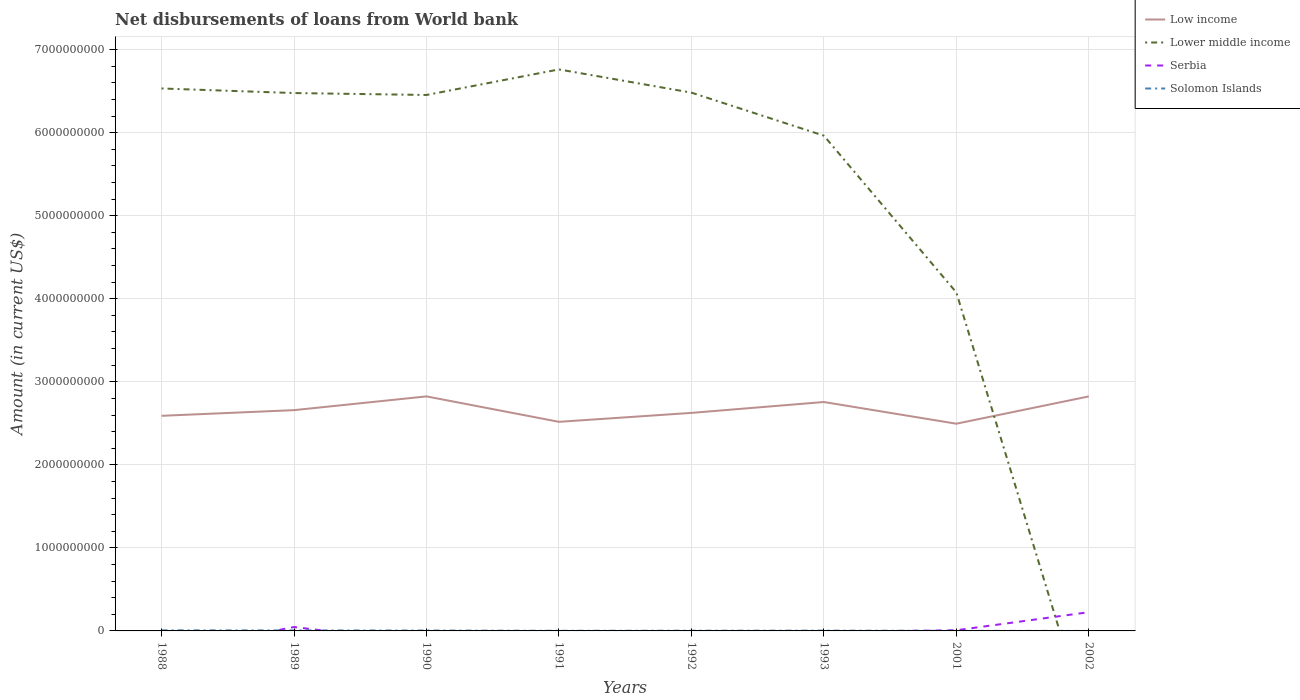Does the line corresponding to Solomon Islands intersect with the line corresponding to Low income?
Your answer should be very brief. No. What is the total amount of loan disbursed from World Bank in Low income in the graph?
Your answer should be very brief. -2.34e+08. What is the difference between the highest and the second highest amount of loan disbursed from World Bank in Lower middle income?
Your answer should be very brief. 6.76e+09. Is the amount of loan disbursed from World Bank in Solomon Islands strictly greater than the amount of loan disbursed from World Bank in Low income over the years?
Ensure brevity in your answer.  Yes. Are the values on the major ticks of Y-axis written in scientific E-notation?
Your response must be concise. No. Does the graph contain grids?
Keep it short and to the point. Yes. How are the legend labels stacked?
Offer a terse response. Vertical. What is the title of the graph?
Offer a very short reply. Net disbursements of loans from World bank. Does "Maldives" appear as one of the legend labels in the graph?
Keep it short and to the point. No. What is the label or title of the X-axis?
Make the answer very short. Years. What is the Amount (in current US$) in Low income in 1988?
Ensure brevity in your answer.  2.59e+09. What is the Amount (in current US$) of Lower middle income in 1988?
Your answer should be compact. 6.53e+09. What is the Amount (in current US$) in Solomon Islands in 1988?
Ensure brevity in your answer.  7.18e+06. What is the Amount (in current US$) in Low income in 1989?
Your response must be concise. 2.66e+09. What is the Amount (in current US$) in Lower middle income in 1989?
Your answer should be very brief. 6.48e+09. What is the Amount (in current US$) in Serbia in 1989?
Offer a very short reply. 4.69e+07. What is the Amount (in current US$) of Solomon Islands in 1989?
Provide a short and direct response. 6.07e+06. What is the Amount (in current US$) of Low income in 1990?
Your answer should be very brief. 2.82e+09. What is the Amount (in current US$) in Lower middle income in 1990?
Keep it short and to the point. 6.45e+09. What is the Amount (in current US$) in Serbia in 1990?
Give a very brief answer. 0. What is the Amount (in current US$) of Solomon Islands in 1990?
Ensure brevity in your answer.  4.68e+06. What is the Amount (in current US$) in Low income in 1991?
Offer a very short reply. 2.52e+09. What is the Amount (in current US$) in Lower middle income in 1991?
Your answer should be very brief. 6.76e+09. What is the Amount (in current US$) of Solomon Islands in 1991?
Keep it short and to the point. 1.68e+06. What is the Amount (in current US$) of Low income in 1992?
Offer a terse response. 2.63e+09. What is the Amount (in current US$) in Lower middle income in 1992?
Ensure brevity in your answer.  6.48e+09. What is the Amount (in current US$) in Solomon Islands in 1992?
Your answer should be compact. 2.63e+06. What is the Amount (in current US$) in Low income in 1993?
Give a very brief answer. 2.76e+09. What is the Amount (in current US$) in Lower middle income in 1993?
Offer a terse response. 5.96e+09. What is the Amount (in current US$) of Solomon Islands in 1993?
Provide a short and direct response. 3.58e+06. What is the Amount (in current US$) in Low income in 2001?
Provide a succinct answer. 2.50e+09. What is the Amount (in current US$) of Lower middle income in 2001?
Give a very brief answer. 4.08e+09. What is the Amount (in current US$) of Serbia in 2001?
Your answer should be compact. 7.92e+06. What is the Amount (in current US$) of Solomon Islands in 2001?
Provide a short and direct response. 9.77e+05. What is the Amount (in current US$) in Low income in 2002?
Offer a very short reply. 2.82e+09. What is the Amount (in current US$) in Lower middle income in 2002?
Your answer should be very brief. 0. What is the Amount (in current US$) in Serbia in 2002?
Provide a short and direct response. 2.26e+08. What is the Amount (in current US$) in Solomon Islands in 2002?
Your response must be concise. 0. Across all years, what is the maximum Amount (in current US$) in Low income?
Your response must be concise. 2.82e+09. Across all years, what is the maximum Amount (in current US$) of Lower middle income?
Offer a terse response. 6.76e+09. Across all years, what is the maximum Amount (in current US$) in Serbia?
Offer a very short reply. 2.26e+08. Across all years, what is the maximum Amount (in current US$) of Solomon Islands?
Your answer should be very brief. 7.18e+06. Across all years, what is the minimum Amount (in current US$) of Low income?
Provide a short and direct response. 2.50e+09. Across all years, what is the minimum Amount (in current US$) in Serbia?
Offer a terse response. 0. Across all years, what is the minimum Amount (in current US$) of Solomon Islands?
Make the answer very short. 0. What is the total Amount (in current US$) of Low income in the graph?
Your answer should be compact. 2.13e+1. What is the total Amount (in current US$) of Lower middle income in the graph?
Offer a very short reply. 4.27e+1. What is the total Amount (in current US$) of Serbia in the graph?
Provide a succinct answer. 2.81e+08. What is the total Amount (in current US$) of Solomon Islands in the graph?
Give a very brief answer. 2.68e+07. What is the difference between the Amount (in current US$) in Low income in 1988 and that in 1989?
Provide a succinct answer. -6.82e+07. What is the difference between the Amount (in current US$) of Lower middle income in 1988 and that in 1989?
Your response must be concise. 5.51e+07. What is the difference between the Amount (in current US$) of Solomon Islands in 1988 and that in 1989?
Your answer should be very brief. 1.12e+06. What is the difference between the Amount (in current US$) in Low income in 1988 and that in 1990?
Your answer should be very brief. -2.34e+08. What is the difference between the Amount (in current US$) of Lower middle income in 1988 and that in 1990?
Offer a very short reply. 7.83e+07. What is the difference between the Amount (in current US$) of Solomon Islands in 1988 and that in 1990?
Give a very brief answer. 2.51e+06. What is the difference between the Amount (in current US$) of Low income in 1988 and that in 1991?
Offer a terse response. 7.25e+07. What is the difference between the Amount (in current US$) in Lower middle income in 1988 and that in 1991?
Provide a short and direct response. -2.29e+08. What is the difference between the Amount (in current US$) of Solomon Islands in 1988 and that in 1991?
Provide a succinct answer. 5.50e+06. What is the difference between the Amount (in current US$) of Low income in 1988 and that in 1992?
Keep it short and to the point. -3.51e+07. What is the difference between the Amount (in current US$) in Lower middle income in 1988 and that in 1992?
Your answer should be compact. 5.02e+07. What is the difference between the Amount (in current US$) of Solomon Islands in 1988 and that in 1992?
Offer a very short reply. 4.55e+06. What is the difference between the Amount (in current US$) of Low income in 1988 and that in 1993?
Offer a very short reply. -1.66e+08. What is the difference between the Amount (in current US$) in Lower middle income in 1988 and that in 1993?
Your response must be concise. 5.68e+08. What is the difference between the Amount (in current US$) in Solomon Islands in 1988 and that in 1993?
Provide a short and direct response. 3.60e+06. What is the difference between the Amount (in current US$) in Low income in 1988 and that in 2001?
Your response must be concise. 9.52e+07. What is the difference between the Amount (in current US$) of Lower middle income in 1988 and that in 2001?
Offer a very short reply. 2.46e+09. What is the difference between the Amount (in current US$) in Solomon Islands in 1988 and that in 2001?
Provide a short and direct response. 6.21e+06. What is the difference between the Amount (in current US$) in Low income in 1988 and that in 2002?
Your response must be concise. -2.34e+08. What is the difference between the Amount (in current US$) of Low income in 1989 and that in 1990?
Make the answer very short. -1.66e+08. What is the difference between the Amount (in current US$) of Lower middle income in 1989 and that in 1990?
Offer a very short reply. 2.32e+07. What is the difference between the Amount (in current US$) of Solomon Islands in 1989 and that in 1990?
Provide a succinct answer. 1.39e+06. What is the difference between the Amount (in current US$) in Low income in 1989 and that in 1991?
Offer a terse response. 1.41e+08. What is the difference between the Amount (in current US$) of Lower middle income in 1989 and that in 1991?
Keep it short and to the point. -2.84e+08. What is the difference between the Amount (in current US$) in Solomon Islands in 1989 and that in 1991?
Your response must be concise. 4.39e+06. What is the difference between the Amount (in current US$) in Low income in 1989 and that in 1992?
Your answer should be very brief. 3.31e+07. What is the difference between the Amount (in current US$) in Lower middle income in 1989 and that in 1992?
Offer a very short reply. -4.91e+06. What is the difference between the Amount (in current US$) of Solomon Islands in 1989 and that in 1992?
Your answer should be very brief. 3.43e+06. What is the difference between the Amount (in current US$) of Low income in 1989 and that in 1993?
Ensure brevity in your answer.  -9.79e+07. What is the difference between the Amount (in current US$) of Lower middle income in 1989 and that in 1993?
Ensure brevity in your answer.  5.13e+08. What is the difference between the Amount (in current US$) of Solomon Islands in 1989 and that in 1993?
Provide a short and direct response. 2.49e+06. What is the difference between the Amount (in current US$) in Low income in 1989 and that in 2001?
Keep it short and to the point. 1.63e+08. What is the difference between the Amount (in current US$) of Lower middle income in 1989 and that in 2001?
Provide a short and direct response. 2.40e+09. What is the difference between the Amount (in current US$) of Serbia in 1989 and that in 2001?
Keep it short and to the point. 3.90e+07. What is the difference between the Amount (in current US$) in Solomon Islands in 1989 and that in 2001?
Offer a terse response. 5.09e+06. What is the difference between the Amount (in current US$) of Low income in 1989 and that in 2002?
Give a very brief answer. -1.65e+08. What is the difference between the Amount (in current US$) of Serbia in 1989 and that in 2002?
Keep it short and to the point. -1.79e+08. What is the difference between the Amount (in current US$) of Low income in 1990 and that in 1991?
Offer a terse response. 3.06e+08. What is the difference between the Amount (in current US$) of Lower middle income in 1990 and that in 1991?
Keep it short and to the point. -3.08e+08. What is the difference between the Amount (in current US$) of Solomon Islands in 1990 and that in 1991?
Ensure brevity in your answer.  3.00e+06. What is the difference between the Amount (in current US$) in Low income in 1990 and that in 1992?
Your response must be concise. 1.99e+08. What is the difference between the Amount (in current US$) of Lower middle income in 1990 and that in 1992?
Your answer should be compact. -2.81e+07. What is the difference between the Amount (in current US$) in Solomon Islands in 1990 and that in 1992?
Your response must be concise. 2.04e+06. What is the difference between the Amount (in current US$) of Low income in 1990 and that in 1993?
Keep it short and to the point. 6.77e+07. What is the difference between the Amount (in current US$) in Lower middle income in 1990 and that in 1993?
Provide a short and direct response. 4.90e+08. What is the difference between the Amount (in current US$) of Solomon Islands in 1990 and that in 1993?
Your answer should be compact. 1.10e+06. What is the difference between the Amount (in current US$) of Low income in 1990 and that in 2001?
Give a very brief answer. 3.29e+08. What is the difference between the Amount (in current US$) in Lower middle income in 1990 and that in 2001?
Ensure brevity in your answer.  2.38e+09. What is the difference between the Amount (in current US$) in Solomon Islands in 1990 and that in 2001?
Provide a short and direct response. 3.70e+06. What is the difference between the Amount (in current US$) of Low income in 1990 and that in 2002?
Give a very brief answer. 9.60e+04. What is the difference between the Amount (in current US$) of Low income in 1991 and that in 1992?
Your answer should be compact. -1.08e+08. What is the difference between the Amount (in current US$) in Lower middle income in 1991 and that in 1992?
Keep it short and to the point. 2.80e+08. What is the difference between the Amount (in current US$) in Solomon Islands in 1991 and that in 1992?
Your response must be concise. -9.54e+05. What is the difference between the Amount (in current US$) of Low income in 1991 and that in 1993?
Your response must be concise. -2.39e+08. What is the difference between the Amount (in current US$) in Lower middle income in 1991 and that in 1993?
Ensure brevity in your answer.  7.98e+08. What is the difference between the Amount (in current US$) in Solomon Islands in 1991 and that in 1993?
Keep it short and to the point. -1.90e+06. What is the difference between the Amount (in current US$) in Low income in 1991 and that in 2001?
Offer a terse response. 2.27e+07. What is the difference between the Amount (in current US$) of Lower middle income in 1991 and that in 2001?
Offer a terse response. 2.69e+09. What is the difference between the Amount (in current US$) of Solomon Islands in 1991 and that in 2001?
Offer a very short reply. 7.02e+05. What is the difference between the Amount (in current US$) in Low income in 1991 and that in 2002?
Keep it short and to the point. -3.06e+08. What is the difference between the Amount (in current US$) of Low income in 1992 and that in 1993?
Give a very brief answer. -1.31e+08. What is the difference between the Amount (in current US$) of Lower middle income in 1992 and that in 1993?
Your answer should be compact. 5.18e+08. What is the difference between the Amount (in current US$) of Solomon Islands in 1992 and that in 1993?
Keep it short and to the point. -9.46e+05. What is the difference between the Amount (in current US$) of Low income in 1992 and that in 2001?
Offer a very short reply. 1.30e+08. What is the difference between the Amount (in current US$) in Lower middle income in 1992 and that in 2001?
Your response must be concise. 2.41e+09. What is the difference between the Amount (in current US$) of Solomon Islands in 1992 and that in 2001?
Your answer should be very brief. 1.66e+06. What is the difference between the Amount (in current US$) of Low income in 1992 and that in 2002?
Your answer should be compact. -1.99e+08. What is the difference between the Amount (in current US$) of Low income in 1993 and that in 2001?
Offer a terse response. 2.61e+08. What is the difference between the Amount (in current US$) in Lower middle income in 1993 and that in 2001?
Your answer should be compact. 1.89e+09. What is the difference between the Amount (in current US$) in Solomon Islands in 1993 and that in 2001?
Your response must be concise. 2.60e+06. What is the difference between the Amount (in current US$) of Low income in 1993 and that in 2002?
Give a very brief answer. -6.76e+07. What is the difference between the Amount (in current US$) of Low income in 2001 and that in 2002?
Keep it short and to the point. -3.29e+08. What is the difference between the Amount (in current US$) in Serbia in 2001 and that in 2002?
Your response must be concise. -2.18e+08. What is the difference between the Amount (in current US$) of Low income in 1988 and the Amount (in current US$) of Lower middle income in 1989?
Make the answer very short. -3.89e+09. What is the difference between the Amount (in current US$) of Low income in 1988 and the Amount (in current US$) of Serbia in 1989?
Provide a short and direct response. 2.54e+09. What is the difference between the Amount (in current US$) in Low income in 1988 and the Amount (in current US$) in Solomon Islands in 1989?
Offer a terse response. 2.58e+09. What is the difference between the Amount (in current US$) of Lower middle income in 1988 and the Amount (in current US$) of Serbia in 1989?
Your answer should be very brief. 6.49e+09. What is the difference between the Amount (in current US$) of Lower middle income in 1988 and the Amount (in current US$) of Solomon Islands in 1989?
Your answer should be very brief. 6.53e+09. What is the difference between the Amount (in current US$) in Low income in 1988 and the Amount (in current US$) in Lower middle income in 1990?
Your answer should be compact. -3.86e+09. What is the difference between the Amount (in current US$) of Low income in 1988 and the Amount (in current US$) of Solomon Islands in 1990?
Your response must be concise. 2.59e+09. What is the difference between the Amount (in current US$) in Lower middle income in 1988 and the Amount (in current US$) in Solomon Islands in 1990?
Offer a terse response. 6.53e+09. What is the difference between the Amount (in current US$) of Low income in 1988 and the Amount (in current US$) of Lower middle income in 1991?
Your answer should be very brief. -4.17e+09. What is the difference between the Amount (in current US$) in Low income in 1988 and the Amount (in current US$) in Solomon Islands in 1991?
Your answer should be compact. 2.59e+09. What is the difference between the Amount (in current US$) of Lower middle income in 1988 and the Amount (in current US$) of Solomon Islands in 1991?
Make the answer very short. 6.53e+09. What is the difference between the Amount (in current US$) in Low income in 1988 and the Amount (in current US$) in Lower middle income in 1992?
Ensure brevity in your answer.  -3.89e+09. What is the difference between the Amount (in current US$) of Low income in 1988 and the Amount (in current US$) of Solomon Islands in 1992?
Provide a succinct answer. 2.59e+09. What is the difference between the Amount (in current US$) of Lower middle income in 1988 and the Amount (in current US$) of Solomon Islands in 1992?
Make the answer very short. 6.53e+09. What is the difference between the Amount (in current US$) of Low income in 1988 and the Amount (in current US$) of Lower middle income in 1993?
Keep it short and to the point. -3.37e+09. What is the difference between the Amount (in current US$) in Low income in 1988 and the Amount (in current US$) in Solomon Islands in 1993?
Your answer should be very brief. 2.59e+09. What is the difference between the Amount (in current US$) in Lower middle income in 1988 and the Amount (in current US$) in Solomon Islands in 1993?
Provide a short and direct response. 6.53e+09. What is the difference between the Amount (in current US$) in Low income in 1988 and the Amount (in current US$) in Lower middle income in 2001?
Provide a succinct answer. -1.49e+09. What is the difference between the Amount (in current US$) in Low income in 1988 and the Amount (in current US$) in Serbia in 2001?
Your response must be concise. 2.58e+09. What is the difference between the Amount (in current US$) in Low income in 1988 and the Amount (in current US$) in Solomon Islands in 2001?
Keep it short and to the point. 2.59e+09. What is the difference between the Amount (in current US$) in Lower middle income in 1988 and the Amount (in current US$) in Serbia in 2001?
Offer a terse response. 6.52e+09. What is the difference between the Amount (in current US$) in Lower middle income in 1988 and the Amount (in current US$) in Solomon Islands in 2001?
Your answer should be very brief. 6.53e+09. What is the difference between the Amount (in current US$) of Low income in 1988 and the Amount (in current US$) of Serbia in 2002?
Keep it short and to the point. 2.36e+09. What is the difference between the Amount (in current US$) of Lower middle income in 1988 and the Amount (in current US$) of Serbia in 2002?
Provide a succinct answer. 6.31e+09. What is the difference between the Amount (in current US$) of Low income in 1989 and the Amount (in current US$) of Lower middle income in 1990?
Offer a terse response. -3.80e+09. What is the difference between the Amount (in current US$) in Low income in 1989 and the Amount (in current US$) in Solomon Islands in 1990?
Your response must be concise. 2.65e+09. What is the difference between the Amount (in current US$) of Lower middle income in 1989 and the Amount (in current US$) of Solomon Islands in 1990?
Offer a terse response. 6.47e+09. What is the difference between the Amount (in current US$) in Serbia in 1989 and the Amount (in current US$) in Solomon Islands in 1990?
Provide a short and direct response. 4.22e+07. What is the difference between the Amount (in current US$) in Low income in 1989 and the Amount (in current US$) in Lower middle income in 1991?
Your answer should be very brief. -4.10e+09. What is the difference between the Amount (in current US$) of Low income in 1989 and the Amount (in current US$) of Solomon Islands in 1991?
Make the answer very short. 2.66e+09. What is the difference between the Amount (in current US$) of Lower middle income in 1989 and the Amount (in current US$) of Solomon Islands in 1991?
Provide a succinct answer. 6.48e+09. What is the difference between the Amount (in current US$) in Serbia in 1989 and the Amount (in current US$) in Solomon Islands in 1991?
Ensure brevity in your answer.  4.52e+07. What is the difference between the Amount (in current US$) of Low income in 1989 and the Amount (in current US$) of Lower middle income in 1992?
Your answer should be very brief. -3.82e+09. What is the difference between the Amount (in current US$) in Low income in 1989 and the Amount (in current US$) in Solomon Islands in 1992?
Your response must be concise. 2.66e+09. What is the difference between the Amount (in current US$) of Lower middle income in 1989 and the Amount (in current US$) of Solomon Islands in 1992?
Your answer should be very brief. 6.47e+09. What is the difference between the Amount (in current US$) of Serbia in 1989 and the Amount (in current US$) of Solomon Islands in 1992?
Make the answer very short. 4.43e+07. What is the difference between the Amount (in current US$) of Low income in 1989 and the Amount (in current US$) of Lower middle income in 1993?
Provide a succinct answer. -3.31e+09. What is the difference between the Amount (in current US$) in Low income in 1989 and the Amount (in current US$) in Solomon Islands in 1993?
Give a very brief answer. 2.66e+09. What is the difference between the Amount (in current US$) in Lower middle income in 1989 and the Amount (in current US$) in Solomon Islands in 1993?
Provide a short and direct response. 6.47e+09. What is the difference between the Amount (in current US$) in Serbia in 1989 and the Amount (in current US$) in Solomon Islands in 1993?
Ensure brevity in your answer.  4.33e+07. What is the difference between the Amount (in current US$) in Low income in 1989 and the Amount (in current US$) in Lower middle income in 2001?
Your response must be concise. -1.42e+09. What is the difference between the Amount (in current US$) of Low income in 1989 and the Amount (in current US$) of Serbia in 2001?
Your answer should be very brief. 2.65e+09. What is the difference between the Amount (in current US$) of Low income in 1989 and the Amount (in current US$) of Solomon Islands in 2001?
Your answer should be compact. 2.66e+09. What is the difference between the Amount (in current US$) in Lower middle income in 1989 and the Amount (in current US$) in Serbia in 2001?
Give a very brief answer. 6.47e+09. What is the difference between the Amount (in current US$) of Lower middle income in 1989 and the Amount (in current US$) of Solomon Islands in 2001?
Offer a very short reply. 6.48e+09. What is the difference between the Amount (in current US$) in Serbia in 1989 and the Amount (in current US$) in Solomon Islands in 2001?
Offer a very short reply. 4.59e+07. What is the difference between the Amount (in current US$) in Low income in 1989 and the Amount (in current US$) in Serbia in 2002?
Your answer should be very brief. 2.43e+09. What is the difference between the Amount (in current US$) in Lower middle income in 1989 and the Amount (in current US$) in Serbia in 2002?
Make the answer very short. 6.25e+09. What is the difference between the Amount (in current US$) in Low income in 1990 and the Amount (in current US$) in Lower middle income in 1991?
Provide a short and direct response. -3.94e+09. What is the difference between the Amount (in current US$) of Low income in 1990 and the Amount (in current US$) of Solomon Islands in 1991?
Offer a very short reply. 2.82e+09. What is the difference between the Amount (in current US$) of Lower middle income in 1990 and the Amount (in current US$) of Solomon Islands in 1991?
Ensure brevity in your answer.  6.45e+09. What is the difference between the Amount (in current US$) of Low income in 1990 and the Amount (in current US$) of Lower middle income in 1992?
Keep it short and to the point. -3.66e+09. What is the difference between the Amount (in current US$) of Low income in 1990 and the Amount (in current US$) of Solomon Islands in 1992?
Provide a succinct answer. 2.82e+09. What is the difference between the Amount (in current US$) in Lower middle income in 1990 and the Amount (in current US$) in Solomon Islands in 1992?
Make the answer very short. 6.45e+09. What is the difference between the Amount (in current US$) in Low income in 1990 and the Amount (in current US$) in Lower middle income in 1993?
Offer a very short reply. -3.14e+09. What is the difference between the Amount (in current US$) of Low income in 1990 and the Amount (in current US$) of Solomon Islands in 1993?
Ensure brevity in your answer.  2.82e+09. What is the difference between the Amount (in current US$) of Lower middle income in 1990 and the Amount (in current US$) of Solomon Islands in 1993?
Provide a succinct answer. 6.45e+09. What is the difference between the Amount (in current US$) in Low income in 1990 and the Amount (in current US$) in Lower middle income in 2001?
Your answer should be compact. -1.25e+09. What is the difference between the Amount (in current US$) in Low income in 1990 and the Amount (in current US$) in Serbia in 2001?
Your answer should be compact. 2.82e+09. What is the difference between the Amount (in current US$) in Low income in 1990 and the Amount (in current US$) in Solomon Islands in 2001?
Provide a short and direct response. 2.82e+09. What is the difference between the Amount (in current US$) of Lower middle income in 1990 and the Amount (in current US$) of Serbia in 2001?
Your answer should be very brief. 6.45e+09. What is the difference between the Amount (in current US$) of Lower middle income in 1990 and the Amount (in current US$) of Solomon Islands in 2001?
Your answer should be compact. 6.45e+09. What is the difference between the Amount (in current US$) in Low income in 1990 and the Amount (in current US$) in Serbia in 2002?
Make the answer very short. 2.60e+09. What is the difference between the Amount (in current US$) in Lower middle income in 1990 and the Amount (in current US$) in Serbia in 2002?
Ensure brevity in your answer.  6.23e+09. What is the difference between the Amount (in current US$) of Low income in 1991 and the Amount (in current US$) of Lower middle income in 1992?
Keep it short and to the point. -3.96e+09. What is the difference between the Amount (in current US$) in Low income in 1991 and the Amount (in current US$) in Solomon Islands in 1992?
Ensure brevity in your answer.  2.52e+09. What is the difference between the Amount (in current US$) in Lower middle income in 1991 and the Amount (in current US$) in Solomon Islands in 1992?
Offer a terse response. 6.76e+09. What is the difference between the Amount (in current US$) in Low income in 1991 and the Amount (in current US$) in Lower middle income in 1993?
Offer a terse response. -3.45e+09. What is the difference between the Amount (in current US$) of Low income in 1991 and the Amount (in current US$) of Solomon Islands in 1993?
Make the answer very short. 2.51e+09. What is the difference between the Amount (in current US$) in Lower middle income in 1991 and the Amount (in current US$) in Solomon Islands in 1993?
Your answer should be very brief. 6.76e+09. What is the difference between the Amount (in current US$) in Low income in 1991 and the Amount (in current US$) in Lower middle income in 2001?
Your response must be concise. -1.56e+09. What is the difference between the Amount (in current US$) of Low income in 1991 and the Amount (in current US$) of Serbia in 2001?
Your answer should be compact. 2.51e+09. What is the difference between the Amount (in current US$) in Low income in 1991 and the Amount (in current US$) in Solomon Islands in 2001?
Provide a succinct answer. 2.52e+09. What is the difference between the Amount (in current US$) in Lower middle income in 1991 and the Amount (in current US$) in Serbia in 2001?
Give a very brief answer. 6.75e+09. What is the difference between the Amount (in current US$) in Lower middle income in 1991 and the Amount (in current US$) in Solomon Islands in 2001?
Provide a short and direct response. 6.76e+09. What is the difference between the Amount (in current US$) of Low income in 1991 and the Amount (in current US$) of Serbia in 2002?
Keep it short and to the point. 2.29e+09. What is the difference between the Amount (in current US$) of Lower middle income in 1991 and the Amount (in current US$) of Serbia in 2002?
Your answer should be very brief. 6.54e+09. What is the difference between the Amount (in current US$) of Low income in 1992 and the Amount (in current US$) of Lower middle income in 1993?
Provide a succinct answer. -3.34e+09. What is the difference between the Amount (in current US$) of Low income in 1992 and the Amount (in current US$) of Solomon Islands in 1993?
Offer a very short reply. 2.62e+09. What is the difference between the Amount (in current US$) in Lower middle income in 1992 and the Amount (in current US$) in Solomon Islands in 1993?
Ensure brevity in your answer.  6.48e+09. What is the difference between the Amount (in current US$) of Low income in 1992 and the Amount (in current US$) of Lower middle income in 2001?
Your answer should be compact. -1.45e+09. What is the difference between the Amount (in current US$) in Low income in 1992 and the Amount (in current US$) in Serbia in 2001?
Offer a very short reply. 2.62e+09. What is the difference between the Amount (in current US$) in Low income in 1992 and the Amount (in current US$) in Solomon Islands in 2001?
Give a very brief answer. 2.62e+09. What is the difference between the Amount (in current US$) of Lower middle income in 1992 and the Amount (in current US$) of Serbia in 2001?
Provide a short and direct response. 6.47e+09. What is the difference between the Amount (in current US$) in Lower middle income in 1992 and the Amount (in current US$) in Solomon Islands in 2001?
Your response must be concise. 6.48e+09. What is the difference between the Amount (in current US$) of Low income in 1992 and the Amount (in current US$) of Serbia in 2002?
Your answer should be compact. 2.40e+09. What is the difference between the Amount (in current US$) of Lower middle income in 1992 and the Amount (in current US$) of Serbia in 2002?
Offer a terse response. 6.26e+09. What is the difference between the Amount (in current US$) of Low income in 1993 and the Amount (in current US$) of Lower middle income in 2001?
Offer a terse response. -1.32e+09. What is the difference between the Amount (in current US$) of Low income in 1993 and the Amount (in current US$) of Serbia in 2001?
Provide a short and direct response. 2.75e+09. What is the difference between the Amount (in current US$) in Low income in 1993 and the Amount (in current US$) in Solomon Islands in 2001?
Provide a short and direct response. 2.76e+09. What is the difference between the Amount (in current US$) in Lower middle income in 1993 and the Amount (in current US$) in Serbia in 2001?
Your answer should be compact. 5.96e+09. What is the difference between the Amount (in current US$) of Lower middle income in 1993 and the Amount (in current US$) of Solomon Islands in 2001?
Give a very brief answer. 5.96e+09. What is the difference between the Amount (in current US$) in Low income in 1993 and the Amount (in current US$) in Serbia in 2002?
Make the answer very short. 2.53e+09. What is the difference between the Amount (in current US$) in Lower middle income in 1993 and the Amount (in current US$) in Serbia in 2002?
Provide a short and direct response. 5.74e+09. What is the difference between the Amount (in current US$) of Low income in 2001 and the Amount (in current US$) of Serbia in 2002?
Your answer should be very brief. 2.27e+09. What is the difference between the Amount (in current US$) of Lower middle income in 2001 and the Amount (in current US$) of Serbia in 2002?
Your answer should be compact. 3.85e+09. What is the average Amount (in current US$) in Low income per year?
Offer a terse response. 2.66e+09. What is the average Amount (in current US$) in Lower middle income per year?
Provide a short and direct response. 5.34e+09. What is the average Amount (in current US$) in Serbia per year?
Offer a very short reply. 3.51e+07. What is the average Amount (in current US$) of Solomon Islands per year?
Offer a very short reply. 3.35e+06. In the year 1988, what is the difference between the Amount (in current US$) in Low income and Amount (in current US$) in Lower middle income?
Give a very brief answer. -3.94e+09. In the year 1988, what is the difference between the Amount (in current US$) of Low income and Amount (in current US$) of Solomon Islands?
Keep it short and to the point. 2.58e+09. In the year 1988, what is the difference between the Amount (in current US$) of Lower middle income and Amount (in current US$) of Solomon Islands?
Provide a short and direct response. 6.53e+09. In the year 1989, what is the difference between the Amount (in current US$) in Low income and Amount (in current US$) in Lower middle income?
Offer a very short reply. -3.82e+09. In the year 1989, what is the difference between the Amount (in current US$) in Low income and Amount (in current US$) in Serbia?
Give a very brief answer. 2.61e+09. In the year 1989, what is the difference between the Amount (in current US$) of Low income and Amount (in current US$) of Solomon Islands?
Provide a short and direct response. 2.65e+09. In the year 1989, what is the difference between the Amount (in current US$) in Lower middle income and Amount (in current US$) in Serbia?
Provide a succinct answer. 6.43e+09. In the year 1989, what is the difference between the Amount (in current US$) of Lower middle income and Amount (in current US$) of Solomon Islands?
Your answer should be very brief. 6.47e+09. In the year 1989, what is the difference between the Amount (in current US$) in Serbia and Amount (in current US$) in Solomon Islands?
Keep it short and to the point. 4.08e+07. In the year 1990, what is the difference between the Amount (in current US$) in Low income and Amount (in current US$) in Lower middle income?
Provide a short and direct response. -3.63e+09. In the year 1990, what is the difference between the Amount (in current US$) in Low income and Amount (in current US$) in Solomon Islands?
Offer a terse response. 2.82e+09. In the year 1990, what is the difference between the Amount (in current US$) of Lower middle income and Amount (in current US$) of Solomon Islands?
Offer a very short reply. 6.45e+09. In the year 1991, what is the difference between the Amount (in current US$) in Low income and Amount (in current US$) in Lower middle income?
Ensure brevity in your answer.  -4.24e+09. In the year 1991, what is the difference between the Amount (in current US$) in Low income and Amount (in current US$) in Solomon Islands?
Provide a succinct answer. 2.52e+09. In the year 1991, what is the difference between the Amount (in current US$) of Lower middle income and Amount (in current US$) of Solomon Islands?
Offer a very short reply. 6.76e+09. In the year 1992, what is the difference between the Amount (in current US$) of Low income and Amount (in current US$) of Lower middle income?
Give a very brief answer. -3.86e+09. In the year 1992, what is the difference between the Amount (in current US$) of Low income and Amount (in current US$) of Solomon Islands?
Your response must be concise. 2.62e+09. In the year 1992, what is the difference between the Amount (in current US$) of Lower middle income and Amount (in current US$) of Solomon Islands?
Your answer should be very brief. 6.48e+09. In the year 1993, what is the difference between the Amount (in current US$) in Low income and Amount (in current US$) in Lower middle income?
Provide a short and direct response. -3.21e+09. In the year 1993, what is the difference between the Amount (in current US$) of Low income and Amount (in current US$) of Solomon Islands?
Give a very brief answer. 2.75e+09. In the year 1993, what is the difference between the Amount (in current US$) of Lower middle income and Amount (in current US$) of Solomon Islands?
Offer a terse response. 5.96e+09. In the year 2001, what is the difference between the Amount (in current US$) of Low income and Amount (in current US$) of Lower middle income?
Your answer should be very brief. -1.58e+09. In the year 2001, what is the difference between the Amount (in current US$) in Low income and Amount (in current US$) in Serbia?
Provide a short and direct response. 2.49e+09. In the year 2001, what is the difference between the Amount (in current US$) in Low income and Amount (in current US$) in Solomon Islands?
Provide a short and direct response. 2.49e+09. In the year 2001, what is the difference between the Amount (in current US$) of Lower middle income and Amount (in current US$) of Serbia?
Provide a short and direct response. 4.07e+09. In the year 2001, what is the difference between the Amount (in current US$) of Lower middle income and Amount (in current US$) of Solomon Islands?
Provide a succinct answer. 4.08e+09. In the year 2001, what is the difference between the Amount (in current US$) of Serbia and Amount (in current US$) of Solomon Islands?
Provide a short and direct response. 6.94e+06. In the year 2002, what is the difference between the Amount (in current US$) in Low income and Amount (in current US$) in Serbia?
Your answer should be very brief. 2.60e+09. What is the ratio of the Amount (in current US$) in Low income in 1988 to that in 1989?
Give a very brief answer. 0.97. What is the ratio of the Amount (in current US$) in Lower middle income in 1988 to that in 1989?
Your answer should be compact. 1.01. What is the ratio of the Amount (in current US$) in Solomon Islands in 1988 to that in 1989?
Provide a short and direct response. 1.18. What is the ratio of the Amount (in current US$) of Low income in 1988 to that in 1990?
Keep it short and to the point. 0.92. What is the ratio of the Amount (in current US$) of Lower middle income in 1988 to that in 1990?
Make the answer very short. 1.01. What is the ratio of the Amount (in current US$) in Solomon Islands in 1988 to that in 1990?
Ensure brevity in your answer.  1.54. What is the ratio of the Amount (in current US$) in Low income in 1988 to that in 1991?
Make the answer very short. 1.03. What is the ratio of the Amount (in current US$) in Lower middle income in 1988 to that in 1991?
Your response must be concise. 0.97. What is the ratio of the Amount (in current US$) in Solomon Islands in 1988 to that in 1991?
Ensure brevity in your answer.  4.28. What is the ratio of the Amount (in current US$) in Low income in 1988 to that in 1992?
Ensure brevity in your answer.  0.99. What is the ratio of the Amount (in current US$) of Lower middle income in 1988 to that in 1992?
Your answer should be compact. 1.01. What is the ratio of the Amount (in current US$) in Solomon Islands in 1988 to that in 1992?
Your answer should be very brief. 2.73. What is the ratio of the Amount (in current US$) in Low income in 1988 to that in 1993?
Your answer should be compact. 0.94. What is the ratio of the Amount (in current US$) of Lower middle income in 1988 to that in 1993?
Offer a very short reply. 1.1. What is the ratio of the Amount (in current US$) in Solomon Islands in 1988 to that in 1993?
Make the answer very short. 2.01. What is the ratio of the Amount (in current US$) in Low income in 1988 to that in 2001?
Offer a very short reply. 1.04. What is the ratio of the Amount (in current US$) of Lower middle income in 1988 to that in 2001?
Your answer should be very brief. 1.6. What is the ratio of the Amount (in current US$) in Solomon Islands in 1988 to that in 2001?
Your response must be concise. 7.35. What is the ratio of the Amount (in current US$) of Low income in 1988 to that in 2002?
Ensure brevity in your answer.  0.92. What is the ratio of the Amount (in current US$) in Low income in 1989 to that in 1990?
Your response must be concise. 0.94. What is the ratio of the Amount (in current US$) of Solomon Islands in 1989 to that in 1990?
Offer a terse response. 1.3. What is the ratio of the Amount (in current US$) of Low income in 1989 to that in 1991?
Provide a succinct answer. 1.06. What is the ratio of the Amount (in current US$) in Lower middle income in 1989 to that in 1991?
Your response must be concise. 0.96. What is the ratio of the Amount (in current US$) of Solomon Islands in 1989 to that in 1991?
Provide a succinct answer. 3.61. What is the ratio of the Amount (in current US$) of Low income in 1989 to that in 1992?
Keep it short and to the point. 1.01. What is the ratio of the Amount (in current US$) of Lower middle income in 1989 to that in 1992?
Make the answer very short. 1. What is the ratio of the Amount (in current US$) in Solomon Islands in 1989 to that in 1992?
Provide a short and direct response. 2.3. What is the ratio of the Amount (in current US$) in Low income in 1989 to that in 1993?
Provide a succinct answer. 0.96. What is the ratio of the Amount (in current US$) of Lower middle income in 1989 to that in 1993?
Your answer should be compact. 1.09. What is the ratio of the Amount (in current US$) of Solomon Islands in 1989 to that in 1993?
Your answer should be compact. 1.69. What is the ratio of the Amount (in current US$) in Low income in 1989 to that in 2001?
Your answer should be compact. 1.07. What is the ratio of the Amount (in current US$) in Lower middle income in 1989 to that in 2001?
Provide a short and direct response. 1.59. What is the ratio of the Amount (in current US$) in Serbia in 1989 to that in 2001?
Your response must be concise. 5.92. What is the ratio of the Amount (in current US$) of Solomon Islands in 1989 to that in 2001?
Provide a short and direct response. 6.21. What is the ratio of the Amount (in current US$) in Low income in 1989 to that in 2002?
Offer a terse response. 0.94. What is the ratio of the Amount (in current US$) of Serbia in 1989 to that in 2002?
Ensure brevity in your answer.  0.21. What is the ratio of the Amount (in current US$) in Low income in 1990 to that in 1991?
Your answer should be compact. 1.12. What is the ratio of the Amount (in current US$) of Lower middle income in 1990 to that in 1991?
Offer a terse response. 0.95. What is the ratio of the Amount (in current US$) in Solomon Islands in 1990 to that in 1991?
Your response must be concise. 2.79. What is the ratio of the Amount (in current US$) of Low income in 1990 to that in 1992?
Keep it short and to the point. 1.08. What is the ratio of the Amount (in current US$) of Lower middle income in 1990 to that in 1992?
Ensure brevity in your answer.  1. What is the ratio of the Amount (in current US$) in Solomon Islands in 1990 to that in 1992?
Keep it short and to the point. 1.78. What is the ratio of the Amount (in current US$) in Low income in 1990 to that in 1993?
Your response must be concise. 1.02. What is the ratio of the Amount (in current US$) of Lower middle income in 1990 to that in 1993?
Give a very brief answer. 1.08. What is the ratio of the Amount (in current US$) of Solomon Islands in 1990 to that in 1993?
Provide a succinct answer. 1.31. What is the ratio of the Amount (in current US$) of Low income in 1990 to that in 2001?
Your answer should be compact. 1.13. What is the ratio of the Amount (in current US$) in Lower middle income in 1990 to that in 2001?
Make the answer very short. 1.58. What is the ratio of the Amount (in current US$) in Solomon Islands in 1990 to that in 2001?
Provide a short and direct response. 4.79. What is the ratio of the Amount (in current US$) of Lower middle income in 1991 to that in 1992?
Your answer should be very brief. 1.04. What is the ratio of the Amount (in current US$) in Solomon Islands in 1991 to that in 1992?
Keep it short and to the point. 0.64. What is the ratio of the Amount (in current US$) in Low income in 1991 to that in 1993?
Your answer should be compact. 0.91. What is the ratio of the Amount (in current US$) in Lower middle income in 1991 to that in 1993?
Your response must be concise. 1.13. What is the ratio of the Amount (in current US$) of Solomon Islands in 1991 to that in 1993?
Offer a terse response. 0.47. What is the ratio of the Amount (in current US$) of Low income in 1991 to that in 2001?
Provide a succinct answer. 1.01. What is the ratio of the Amount (in current US$) of Lower middle income in 1991 to that in 2001?
Keep it short and to the point. 1.66. What is the ratio of the Amount (in current US$) in Solomon Islands in 1991 to that in 2001?
Offer a very short reply. 1.72. What is the ratio of the Amount (in current US$) of Low income in 1991 to that in 2002?
Make the answer very short. 0.89. What is the ratio of the Amount (in current US$) of Low income in 1992 to that in 1993?
Your response must be concise. 0.95. What is the ratio of the Amount (in current US$) in Lower middle income in 1992 to that in 1993?
Provide a succinct answer. 1.09. What is the ratio of the Amount (in current US$) in Solomon Islands in 1992 to that in 1993?
Your answer should be compact. 0.74. What is the ratio of the Amount (in current US$) of Low income in 1992 to that in 2001?
Provide a short and direct response. 1.05. What is the ratio of the Amount (in current US$) of Lower middle income in 1992 to that in 2001?
Ensure brevity in your answer.  1.59. What is the ratio of the Amount (in current US$) of Solomon Islands in 1992 to that in 2001?
Your response must be concise. 2.69. What is the ratio of the Amount (in current US$) in Low income in 1992 to that in 2002?
Your answer should be compact. 0.93. What is the ratio of the Amount (in current US$) of Low income in 1993 to that in 2001?
Offer a very short reply. 1.1. What is the ratio of the Amount (in current US$) of Lower middle income in 1993 to that in 2001?
Provide a succinct answer. 1.46. What is the ratio of the Amount (in current US$) in Solomon Islands in 1993 to that in 2001?
Provide a succinct answer. 3.66. What is the ratio of the Amount (in current US$) in Low income in 1993 to that in 2002?
Offer a very short reply. 0.98. What is the ratio of the Amount (in current US$) in Low income in 2001 to that in 2002?
Make the answer very short. 0.88. What is the ratio of the Amount (in current US$) of Serbia in 2001 to that in 2002?
Ensure brevity in your answer.  0.04. What is the difference between the highest and the second highest Amount (in current US$) of Low income?
Provide a short and direct response. 9.60e+04. What is the difference between the highest and the second highest Amount (in current US$) in Lower middle income?
Make the answer very short. 2.29e+08. What is the difference between the highest and the second highest Amount (in current US$) in Serbia?
Ensure brevity in your answer.  1.79e+08. What is the difference between the highest and the second highest Amount (in current US$) in Solomon Islands?
Your response must be concise. 1.12e+06. What is the difference between the highest and the lowest Amount (in current US$) of Low income?
Your answer should be compact. 3.29e+08. What is the difference between the highest and the lowest Amount (in current US$) in Lower middle income?
Make the answer very short. 6.76e+09. What is the difference between the highest and the lowest Amount (in current US$) of Serbia?
Provide a short and direct response. 2.26e+08. What is the difference between the highest and the lowest Amount (in current US$) of Solomon Islands?
Make the answer very short. 7.18e+06. 